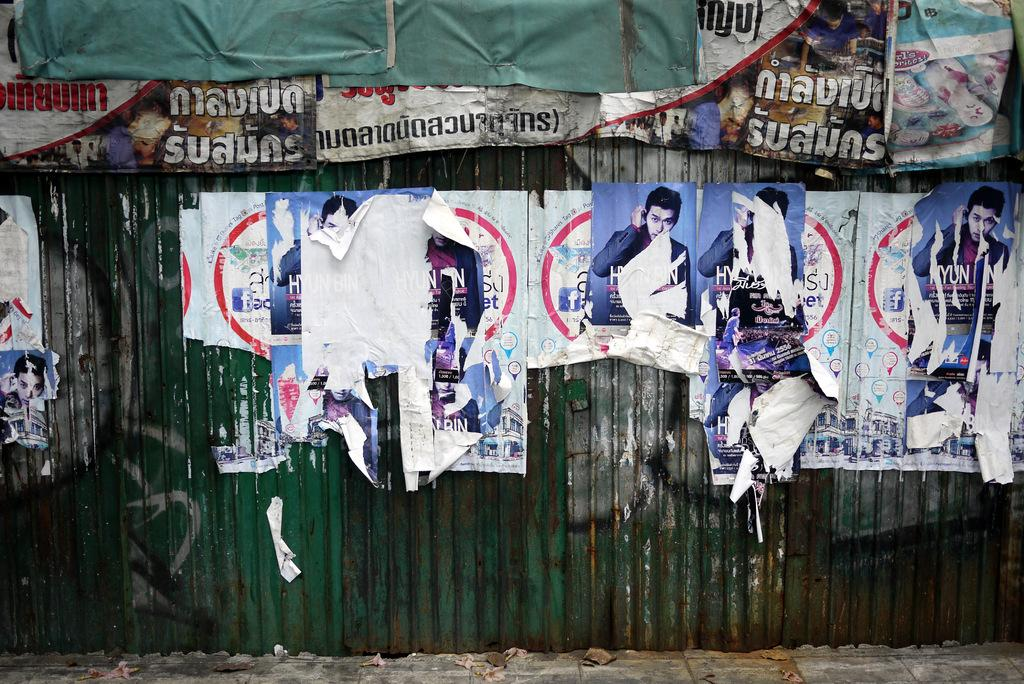What type of materials are the posters and banners made of in the image? The posters and banners are made of paper and are torn in the image. What are the posters and banners attached to in the image? They are attached to metal sheets in the image. What is located at the bottom of the image? There is a platform visible at the bottom of the image. What type of comb is being used to groom the tramp in the image? There is no tramp or comb present in the image. 